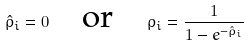<formula> <loc_0><loc_0><loc_500><loc_500>\hat { \rho } _ { i } = 0 \quad \text {or} \quad \rho _ { i } = \frac { 1 } { 1 - e ^ { - \hat { \rho } _ { i } } }</formula> 